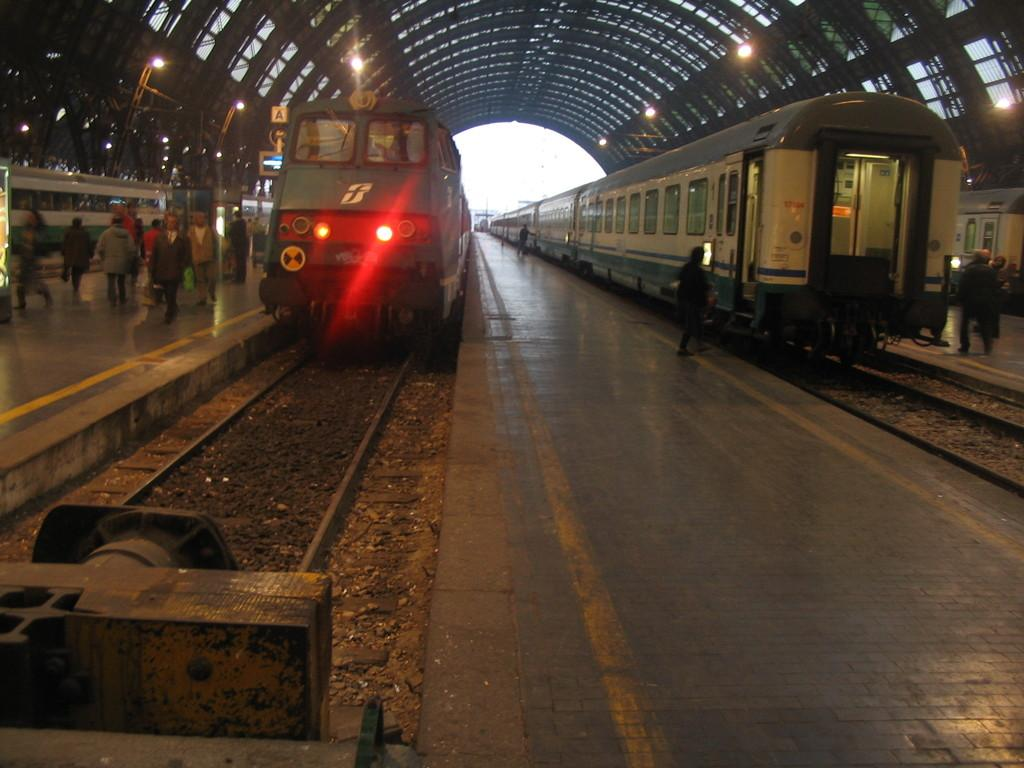What type of vehicles are on the tracks in the image? There are trains on the tracks in the image. What can be seen on the platform in the image? There are people standing on the platform in the image. What is visible in the background of the image? There are lights and the sky visible in the background of the image. What structure is present at the top of the image? There is a roof at the top of the image. How many shoes are being washed in the image? There are no shoes being washed in the image. What type of soap is being used to clean the train in the image? There is no soap or cleaning activity depicted in the image; it shows trains on tracks and people on a platform. 